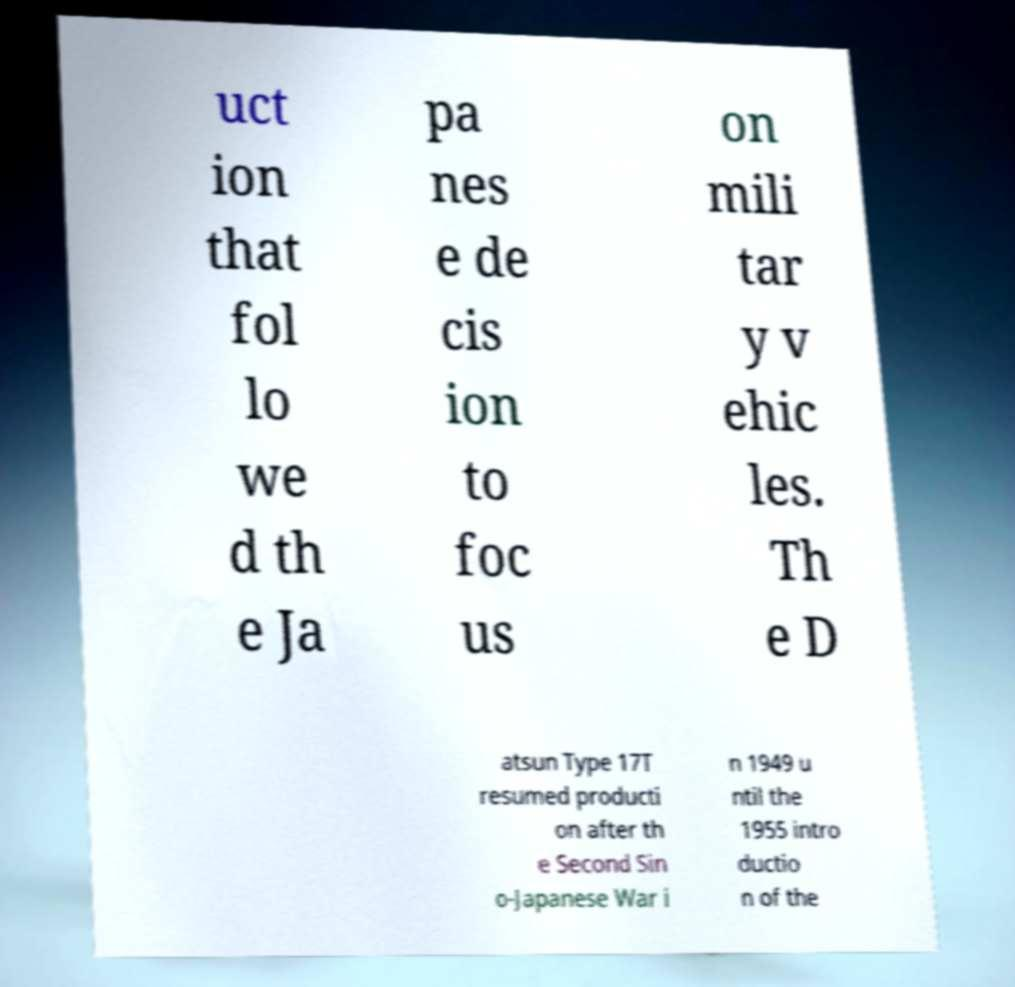For documentation purposes, I need the text within this image transcribed. Could you provide that? uct ion that fol lo we d th e Ja pa nes e de cis ion to foc us on mili tar y v ehic les. Th e D atsun Type 17T resumed producti on after th e Second Sin o-Japanese War i n 1949 u ntil the 1955 intro ductio n of the 